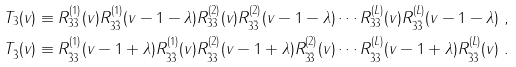Convert formula to latex. <formula><loc_0><loc_0><loc_500><loc_500>& T _ { 3 } ( v ) \equiv R _ { 3 3 } ^ { ( 1 ) } ( v ) R _ { 3 \bar { 3 } } ^ { ( 1 ) } ( v - 1 - \lambda ) R _ { 3 3 } ^ { ( 2 ) } ( v ) R _ { 3 \bar { 3 } } ^ { ( 2 ) } ( v - 1 - \lambda ) \cdots R _ { 3 3 } ^ { ( L ) } ( v ) R _ { 3 \bar { 3 } } ^ { ( L ) } ( v - 1 - \lambda ) \ , \\ & T _ { \bar { 3 } } ( v ) \equiv R _ { \bar { 3 } 3 } ^ { ( 1 ) } ( v - 1 + \lambda ) R _ { \bar { 3 } \bar { 3 } } ^ { ( 1 ) } ( v ) R _ { \bar { 3 } 3 } ^ { ( 2 ) } ( v - 1 + \lambda ) R _ { \bar { 3 } \bar { 3 } } ^ { ( 2 ) } ( v ) \cdots R _ { \bar { 3 } 3 } ^ { ( L ) } ( v - 1 + \lambda ) R _ { \bar { 3 } \bar { 3 } } ^ { ( L ) } ( v ) \ .</formula> 